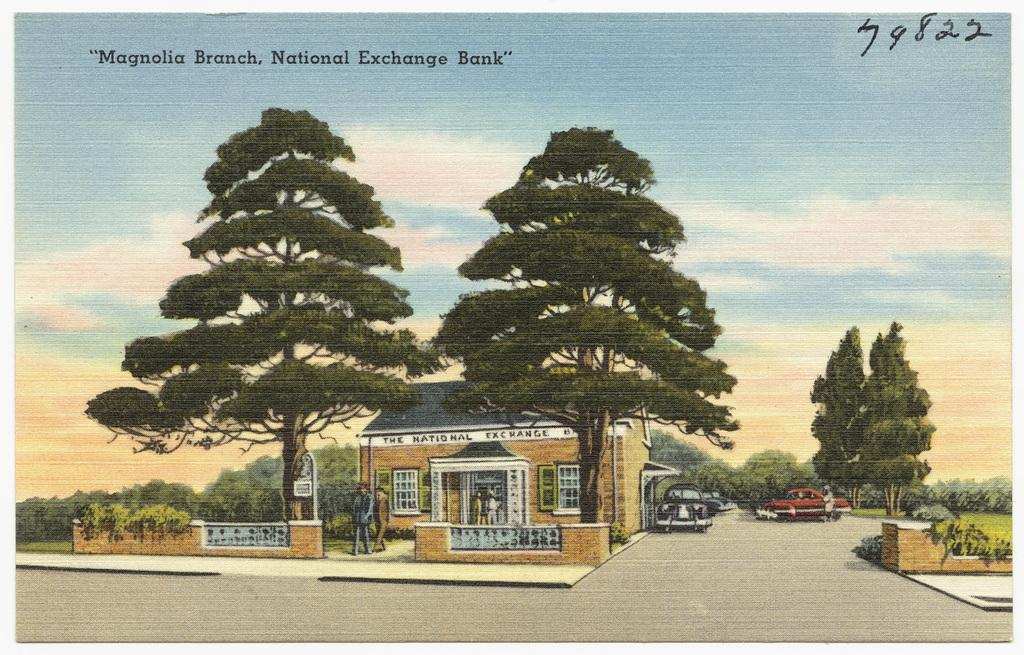What type of structures can be seen in the image? There are houses in the image. What is happening on the road in the image? Vehicles are moving on the road in the image. Are there any living beings present in the image? Yes, there are people in the image. What type of natural elements can be seen in the image? There are trees in the image. What is visible in the background of the image? The sky is visible in the background of the image, and clouds are present in the sky. Is there any text in the image? Yes, there is edited text in the image. How does the family walk on the roof of the house in the image? There is no family or roof of a house present in the image; it features houses, vehicles, people, trees, and edited text. What type of family is walking on the road in the image? There is no family walking on the road in the image; only vehicles are moving on the road. 